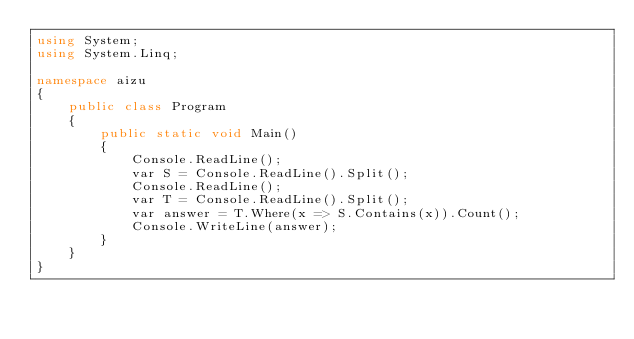Convert code to text. <code><loc_0><loc_0><loc_500><loc_500><_C#_>using System;
using System.Linq;

namespace aizu
{
    public class Program
    {
        public static void Main()
        {
            Console.ReadLine();
            var S = Console.ReadLine().Split();
            Console.ReadLine();
            var T = Console.ReadLine().Split();
            var answer = T.Where(x => S.Contains(x)).Count();
            Console.WriteLine(answer);
        }
    }
}</code> 